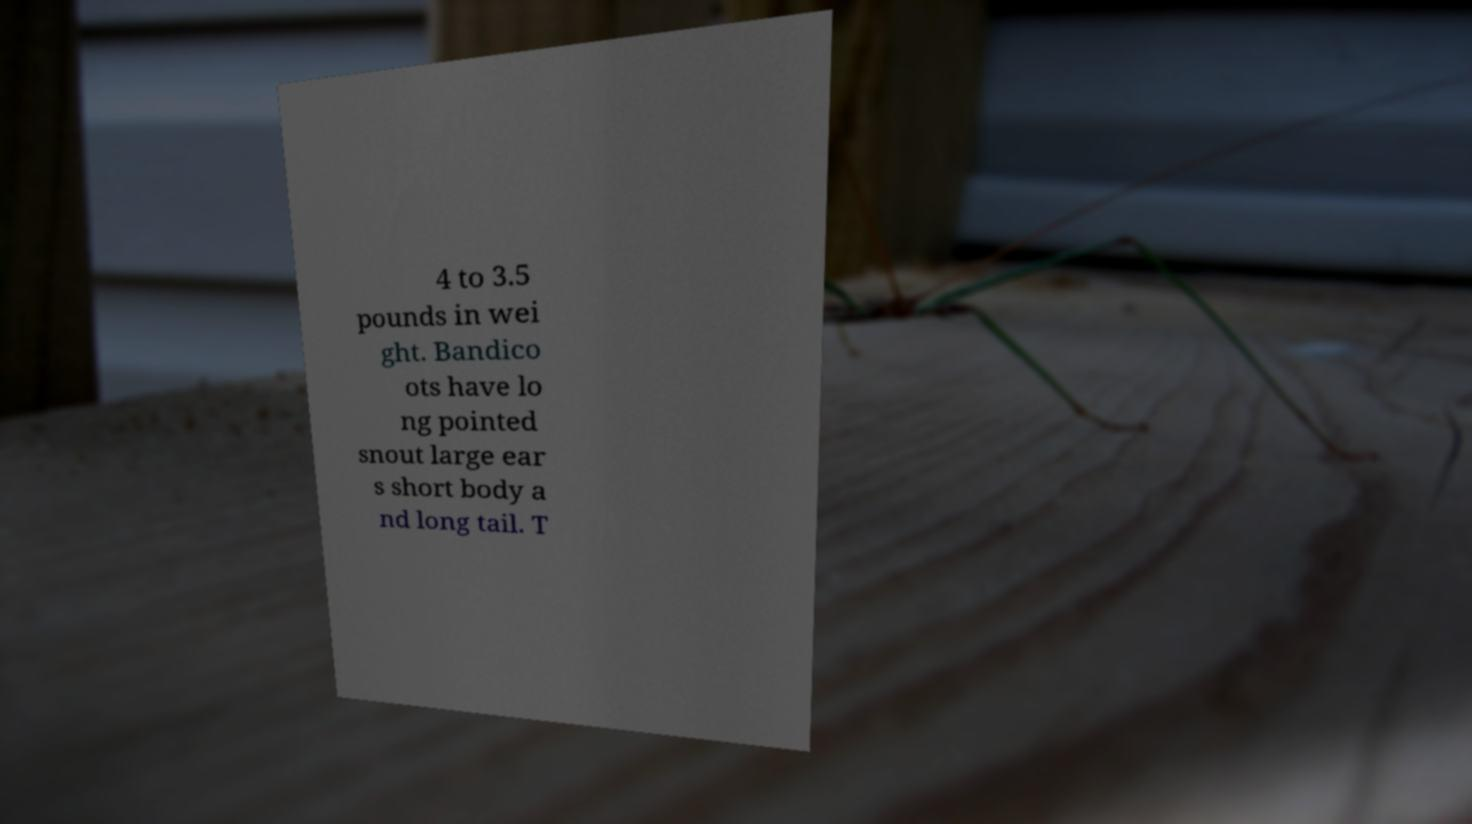There's text embedded in this image that I need extracted. Can you transcribe it verbatim? 4 to 3.5 pounds in wei ght. Bandico ots have lo ng pointed snout large ear s short body a nd long tail. T 